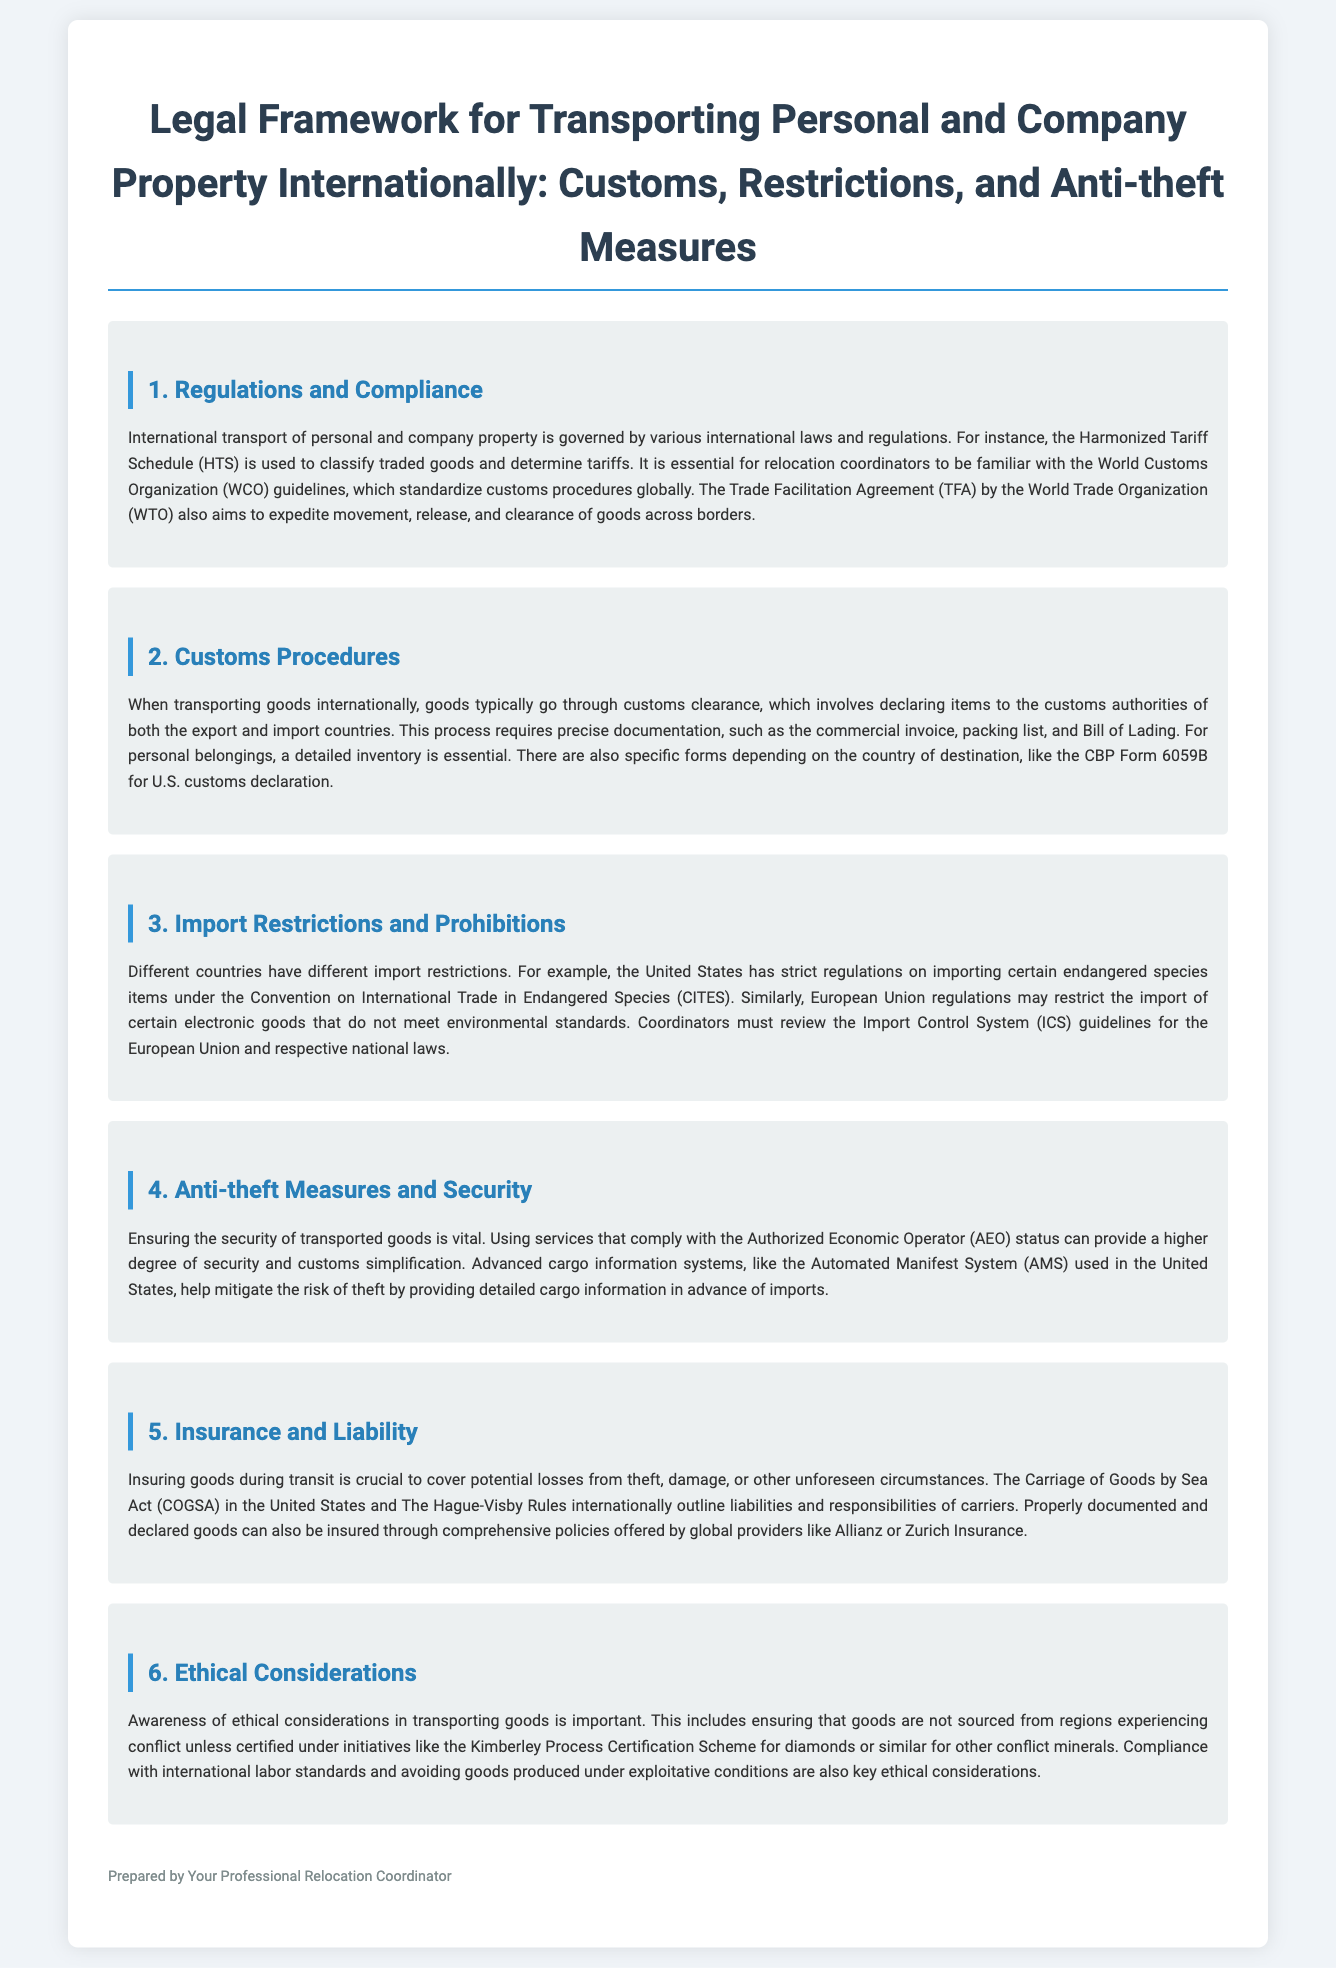What is the HTS used for? The HTS is used to classify traded goods and determine tariffs.
Answer: classifying traded goods What is the specific form for U.S. customs declaration? The specific form mentioned for U.S. customs declaration is CBP Form 6059B.
Answer: CBP Form 6059B Which organization's guidelines should relocation coordinators be familiar with? Relocation coordinators should be familiar with the World Customs Organization (WCO) guidelines.
Answer: World Customs Organization What does AEO stand for? AEO stands for Authorized Economic Operator.
Answer: Authorized Economic Operator What do the Hague-Visby Rules outline? The Hague-Visby Rules outline liabilities and responsibilities of carriers.
Answer: liabilities and responsibilities of carriers Which Act outlines liabilities for goods transported by sea in the U.S.? The Carriage of Goods by Sea Act (COGSA) outlines liabilities for goods transported by sea in the U.S.
Answer: Carriage of Goods by Sea Act What ethical consideration relates to conflict minerals? The Kimberley Process Certification Scheme is an ethical consideration for conflict minerals.
Answer: Kimberley Process Certification Scheme Which agreement aims to expedite the movement of goods across borders? The Trade Facilitation Agreement (TFA) aims to expedite the movement of goods across borders.
Answer: Trade Facilitation Agreement What is a key aspect of securing transported goods? A key aspect of securing transported goods is complying with AEO status.
Answer: complying with AEO status 